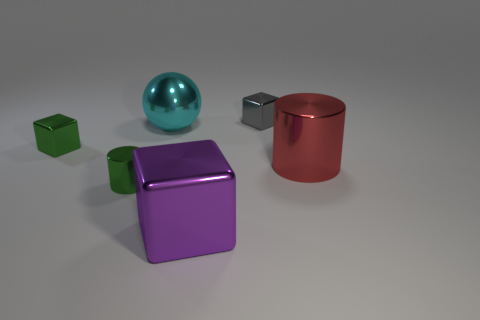There is a tiny green object that is right of the green block; what is its shape?
Offer a terse response. Cylinder. Is there a block made of the same material as the large cyan ball?
Keep it short and to the point. Yes. Do the gray block and the cyan metallic object have the same size?
Your answer should be compact. No. How many blocks are either large cyan metal objects or large brown shiny objects?
Your answer should be very brief. 0. There is a cube that is the same color as the tiny cylinder; what material is it?
Give a very brief answer. Metal. How many gray things are the same shape as the big purple shiny object?
Keep it short and to the point. 1. Are there more metal blocks behind the small green metallic cylinder than purple objects right of the large purple cube?
Provide a succinct answer. Yes. Do the tiny metal block on the left side of the large cyan shiny ball and the tiny cylinder have the same color?
Keep it short and to the point. Yes. What is the size of the gray metal cube?
Your answer should be compact. Small. What color is the large object in front of the red object?
Provide a succinct answer. Purple. 